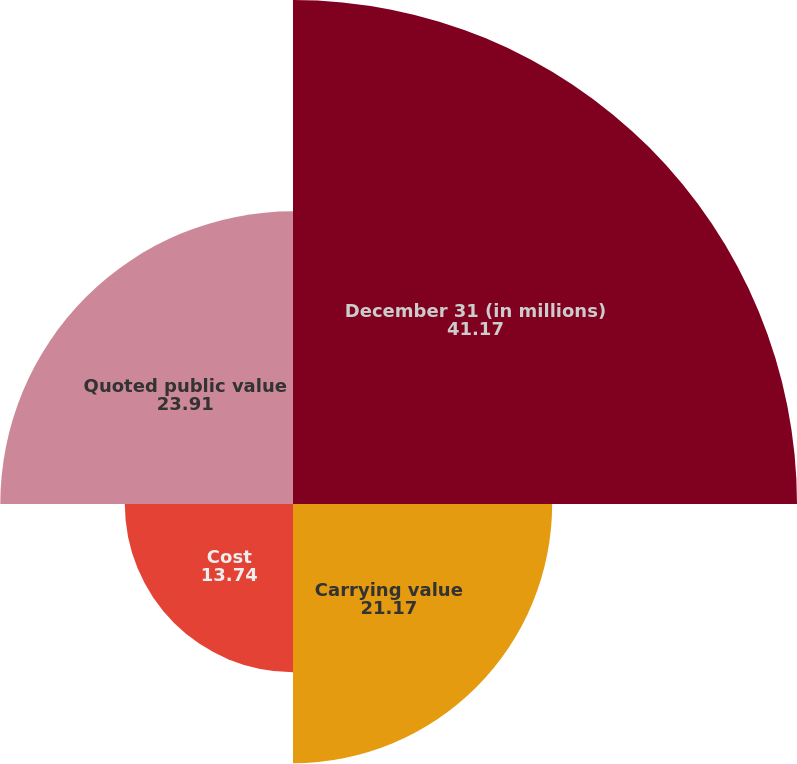Convert chart. <chart><loc_0><loc_0><loc_500><loc_500><pie_chart><fcel>December 31 (in millions)<fcel>Carrying value<fcel>Cost<fcel>Quoted public value<nl><fcel>41.17%<fcel>21.17%<fcel>13.74%<fcel>23.91%<nl></chart> 